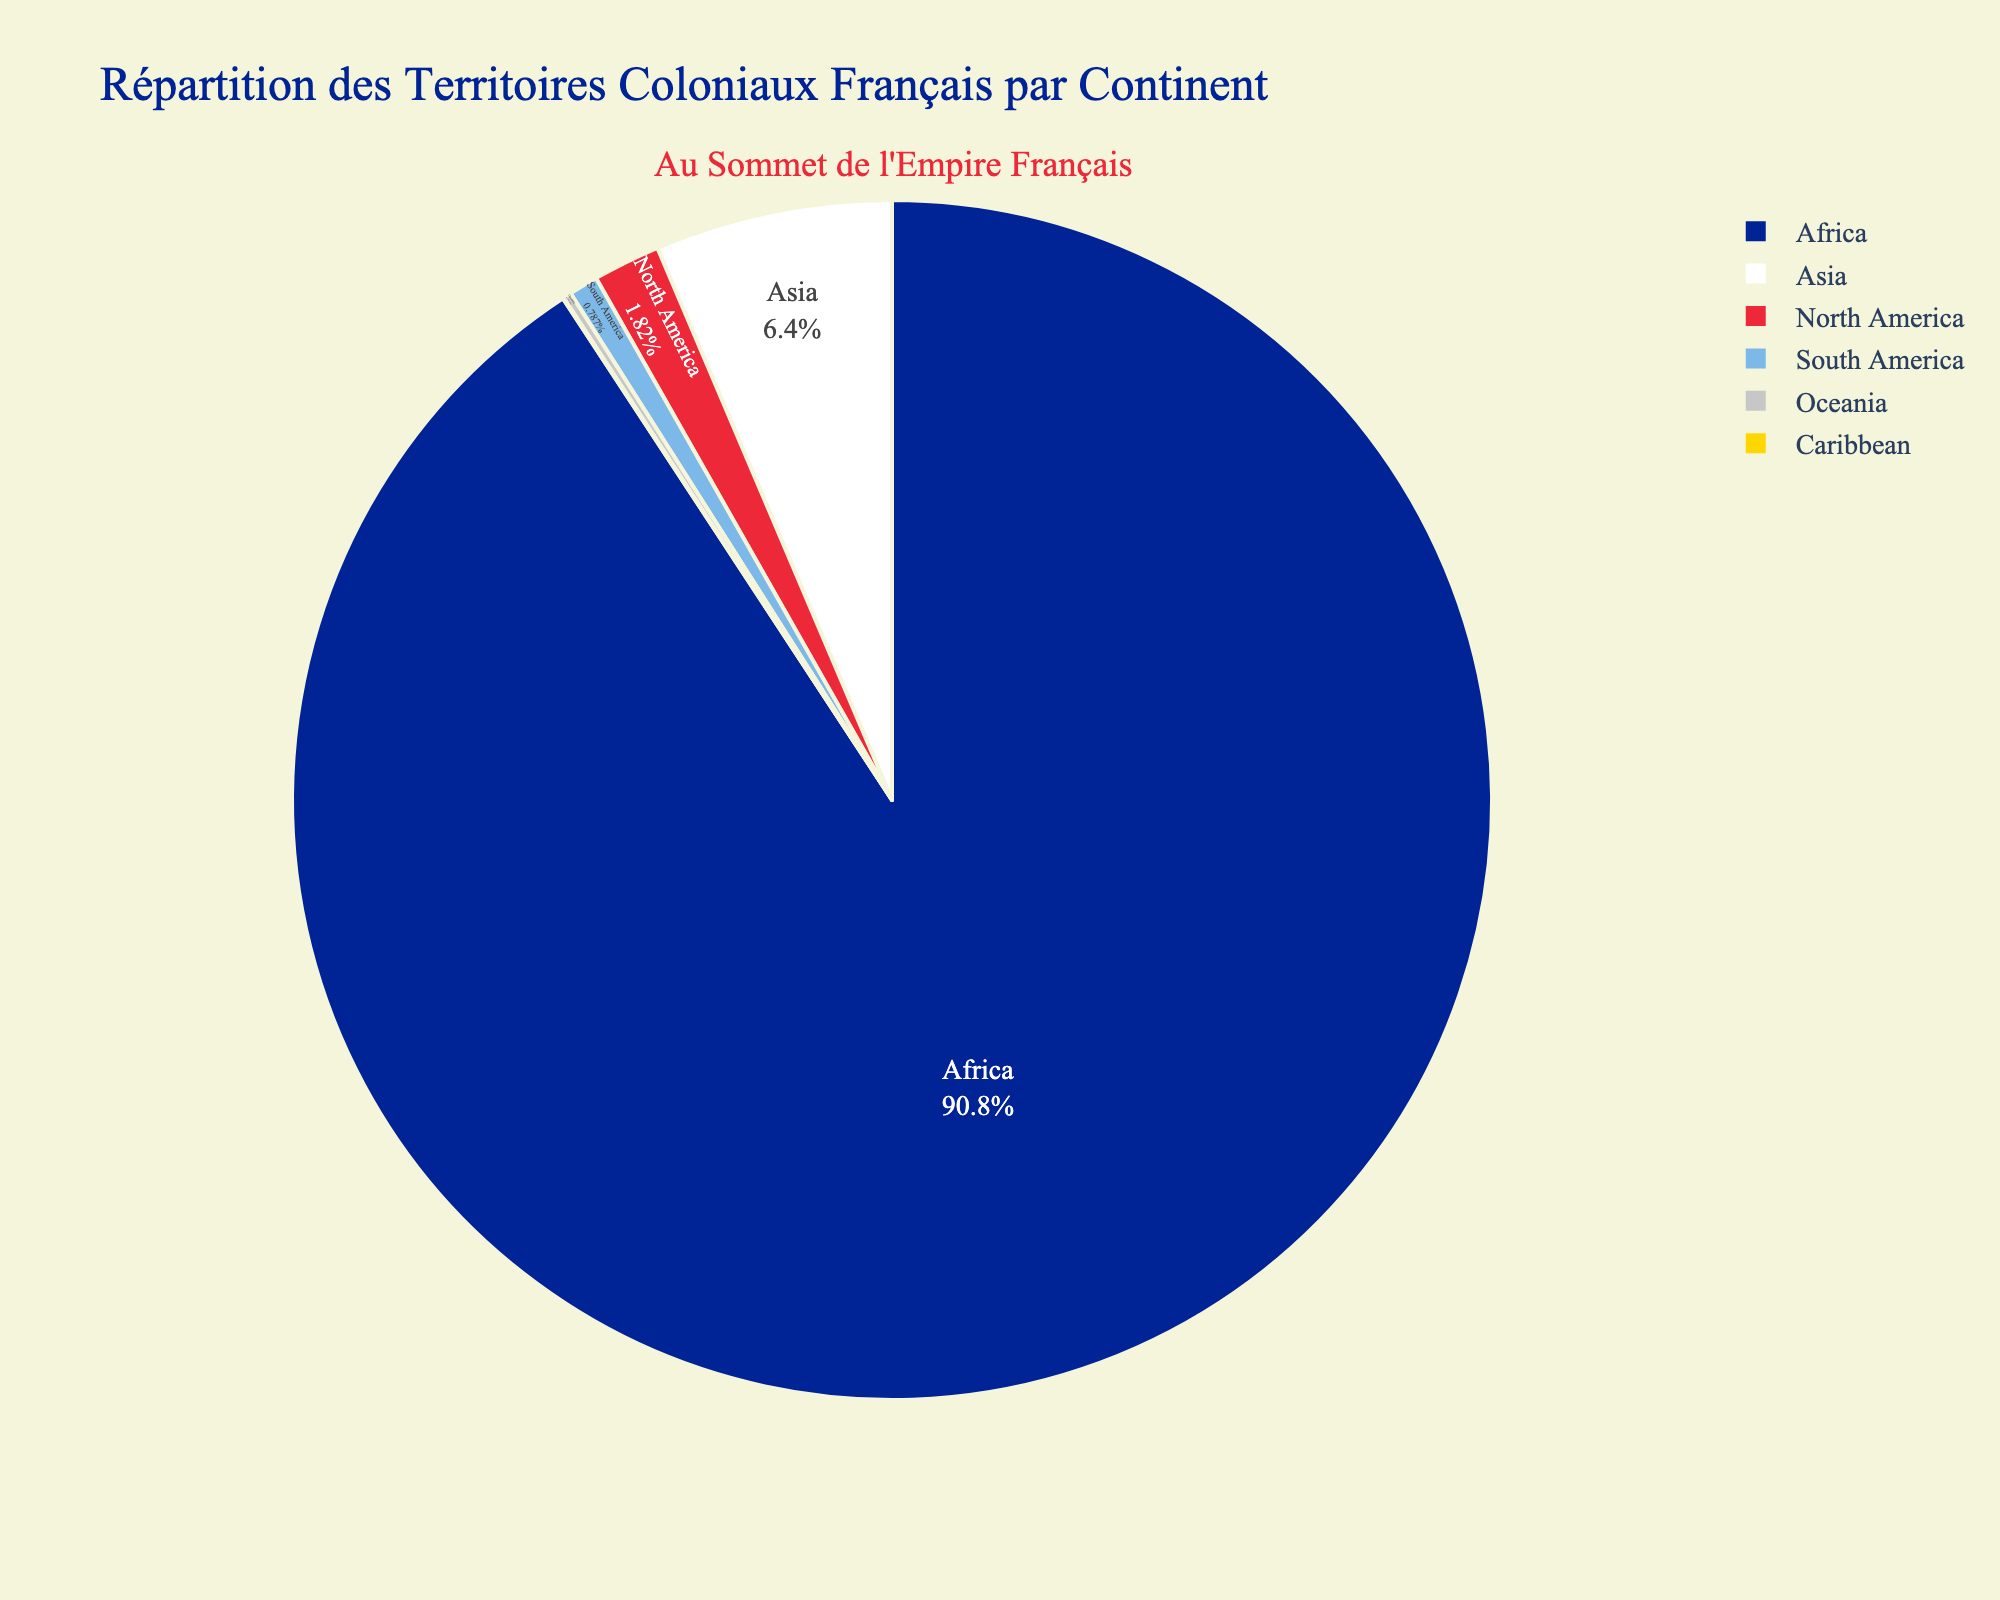What is the largest French colonial territory by continent? By observing the pie chart, the segment representing Africa is clearly the largest, indicating that Africa had the largest French colonial territory area.
Answer: Africa Which continent had a smaller French colonial territory area: North America or Asia? By comparing the segments for North America and Asia, the segment for North America is smaller than the one for Asia. Therefore, North America had a smaller colonial territory area than Asia.
Answer: North America What is the combined area of the French colonial territories in Oceania and the Caribbean? By looking at the chart, the areas for Oceania and the Caribbean are 25,000 km² and 2,830 km², respectively. Adding these areas together gives 25,000 + 2,830 = 27,830 km².
Answer: 27,830 km² Which continent's French colonial territory area is closest to 10 million km²? By observing the chart, Africa's segment is the largest, and the additional title shows it represents 10.5 million km², which is closest to 10 million km².
Answer: Africa What is the smallest French colonial territory by continent? By inspecting the pie chart, the segment for the Caribbean is the smallest, indicating it had the smallest French colonial territory area.
Answer: Caribbean How does the French colonial territory area in South America compare to that in North America? By observing the pie chart, the South America segment is smaller compared to the North America segment, indicating the French colonial territory area in South America is less than that in North America.
Answer: South America Which segments of the pie chart are depicted in white and yellow, and what areas do they represent? Observing the colors used in the pie chart, the white segment represents Asia with 740,000 km², and the yellow segment represents the Caribbean with 2,830 km².
Answer: Asia and Caribbean 